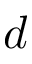<formula> <loc_0><loc_0><loc_500><loc_500>d</formula> 